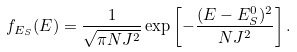Convert formula to latex. <formula><loc_0><loc_0><loc_500><loc_500>f _ { E _ { S } } ( E ) = \frac { 1 } { \sqrt { \pi N J ^ { 2 } } } \exp \left [ - \frac { ( E - E ^ { 0 } _ { S } ) ^ { 2 } } { N J ^ { 2 } } \right ] .</formula> 